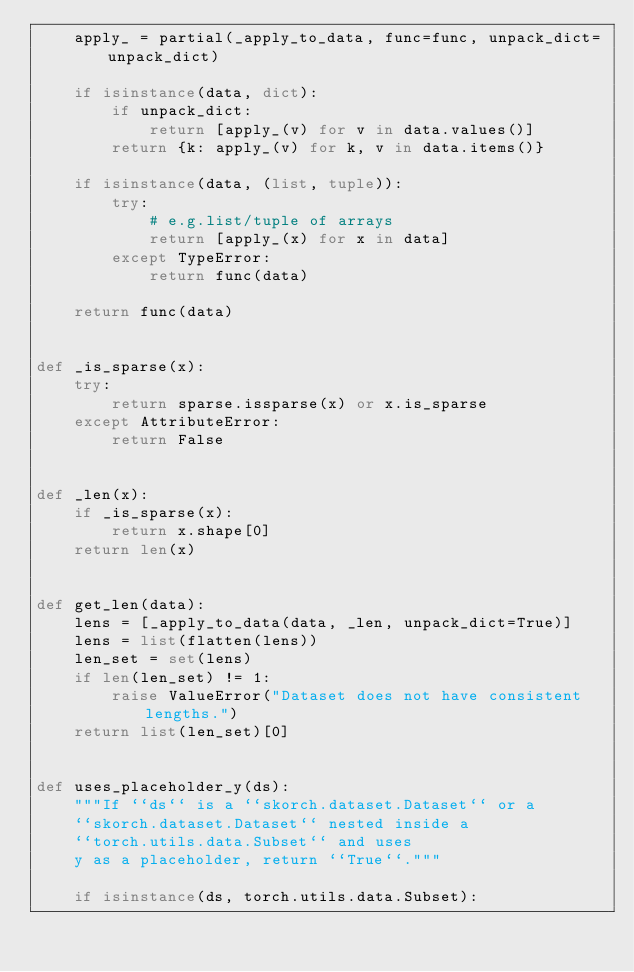<code> <loc_0><loc_0><loc_500><loc_500><_Python_>    apply_ = partial(_apply_to_data, func=func, unpack_dict=unpack_dict)

    if isinstance(data, dict):
        if unpack_dict:
            return [apply_(v) for v in data.values()]
        return {k: apply_(v) for k, v in data.items()}

    if isinstance(data, (list, tuple)):
        try:
            # e.g.list/tuple of arrays
            return [apply_(x) for x in data]
        except TypeError:
            return func(data)

    return func(data)


def _is_sparse(x):
    try:
        return sparse.issparse(x) or x.is_sparse
    except AttributeError:
        return False


def _len(x):
    if _is_sparse(x):
        return x.shape[0]
    return len(x)


def get_len(data):
    lens = [_apply_to_data(data, _len, unpack_dict=True)]
    lens = list(flatten(lens))
    len_set = set(lens)
    if len(len_set) != 1:
        raise ValueError("Dataset does not have consistent lengths.")
    return list(len_set)[0]


def uses_placeholder_y(ds):
    """If ``ds`` is a ``skorch.dataset.Dataset`` or a
    ``skorch.dataset.Dataset`` nested inside a
    ``torch.utils.data.Subset`` and uses
    y as a placeholder, return ``True``."""

    if isinstance(ds, torch.utils.data.Subset):</code> 